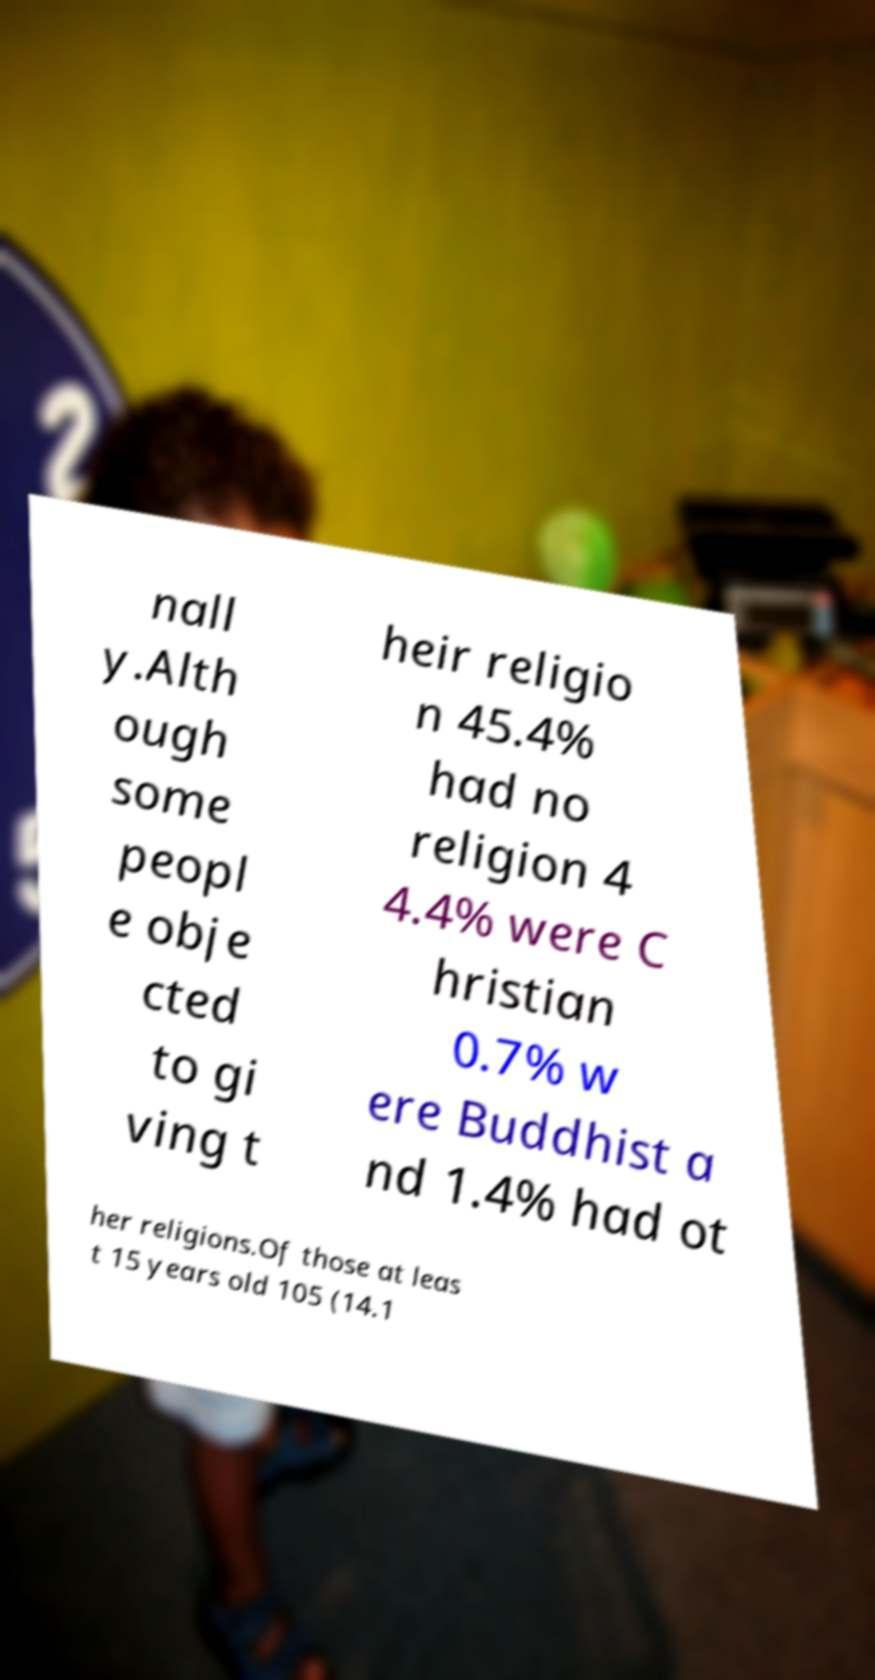I need the written content from this picture converted into text. Can you do that? nall y.Alth ough some peopl e obje cted to gi ving t heir religio n 45.4% had no religion 4 4.4% were C hristian 0.7% w ere Buddhist a nd 1.4% had ot her religions.Of those at leas t 15 years old 105 (14.1 